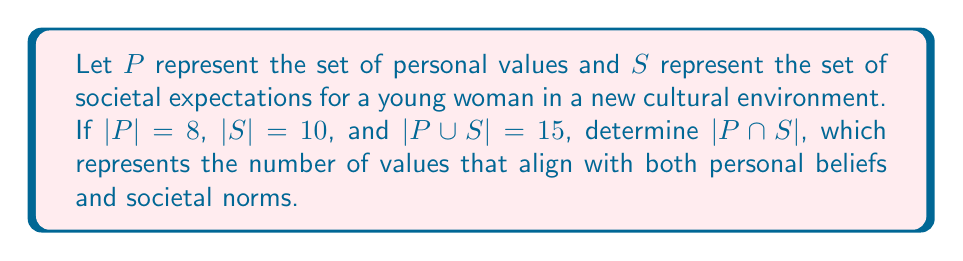Could you help me with this problem? To solve this problem, we'll use the set theory concept of the inclusion-exclusion principle. This principle states that for two sets A and B:

$$|A \cup B| = |A| + |B| - |A \cap B|$$

We're given:
$|P| = 8$ (number of personal values)
$|S| = 10$ (number of societal expectations)
$|P \cup S| = 15$ (total number of unique values and expectations)

Let's plug these into the formula:

$$15 = 8 + 10 - |P \cap S|$$

Now, we can solve for $|P \cap S|$:

$$|P \cap S| = 8 + 10 - 15$$
$$|P \cap S| = 18 - 15$$
$$|P \cap S| = 3$$

This result means that there are 3 values or expectations that are common to both personal values and societal expectations. These represent the intersection of individual beliefs and cultural norms, which could be seen as areas where the young woman's values align with the expectations of her new cultural environment.
Answer: $|P \cap S| = 3$ 